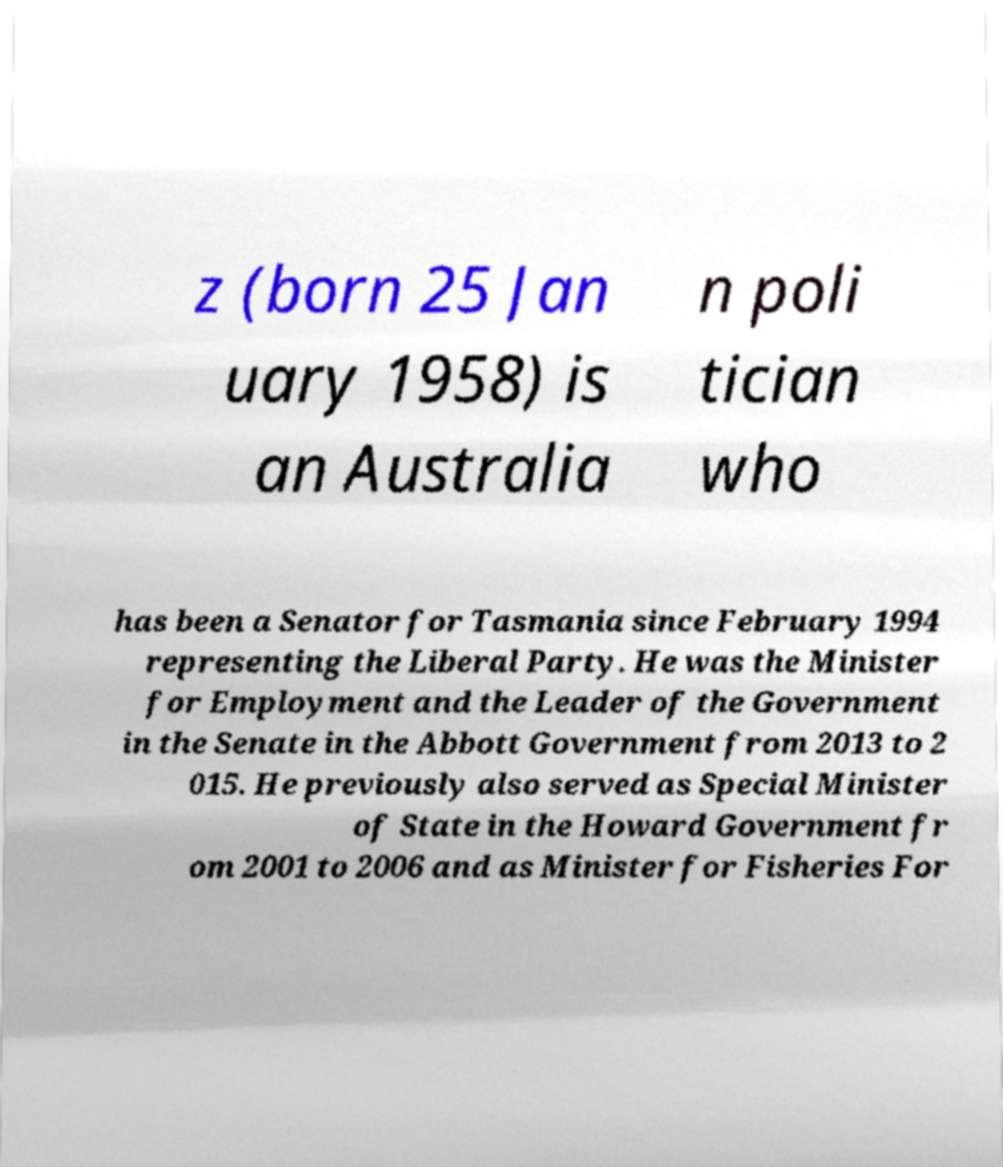I need the written content from this picture converted into text. Can you do that? z (born 25 Jan uary 1958) is an Australia n poli tician who has been a Senator for Tasmania since February 1994 representing the Liberal Party. He was the Minister for Employment and the Leader of the Government in the Senate in the Abbott Government from 2013 to 2 015. He previously also served as Special Minister of State in the Howard Government fr om 2001 to 2006 and as Minister for Fisheries For 